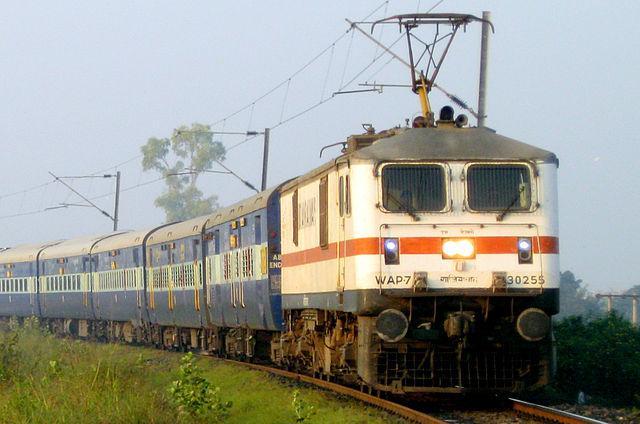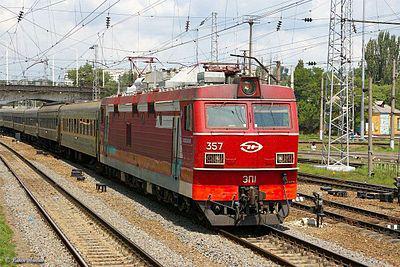The first image is the image on the left, the second image is the image on the right. Analyze the images presented: Is the assertion "The front car of a train is red-orange, and the train is shown at an angle heading down a straight track." valid? Answer yes or no. Yes. The first image is the image on the left, the second image is the image on the right. Given the left and right images, does the statement "Exactly two locomotives are different colors and have different window designs, but are both headed in the same general direction and pulling a line of train cars." hold true? Answer yes or no. Yes. 